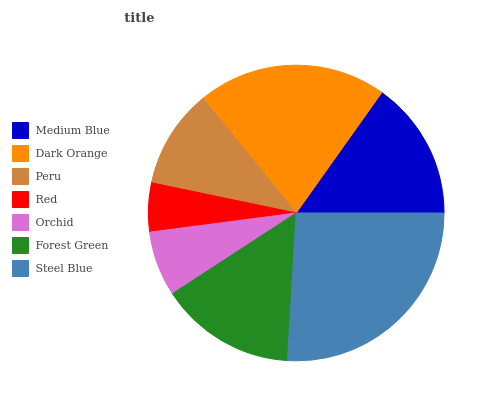Is Red the minimum?
Answer yes or no. Yes. Is Steel Blue the maximum?
Answer yes or no. Yes. Is Dark Orange the minimum?
Answer yes or no. No. Is Dark Orange the maximum?
Answer yes or no. No. Is Dark Orange greater than Medium Blue?
Answer yes or no. Yes. Is Medium Blue less than Dark Orange?
Answer yes or no. Yes. Is Medium Blue greater than Dark Orange?
Answer yes or no. No. Is Dark Orange less than Medium Blue?
Answer yes or no. No. Is Forest Green the high median?
Answer yes or no. Yes. Is Forest Green the low median?
Answer yes or no. Yes. Is Orchid the high median?
Answer yes or no. No. Is Red the low median?
Answer yes or no. No. 